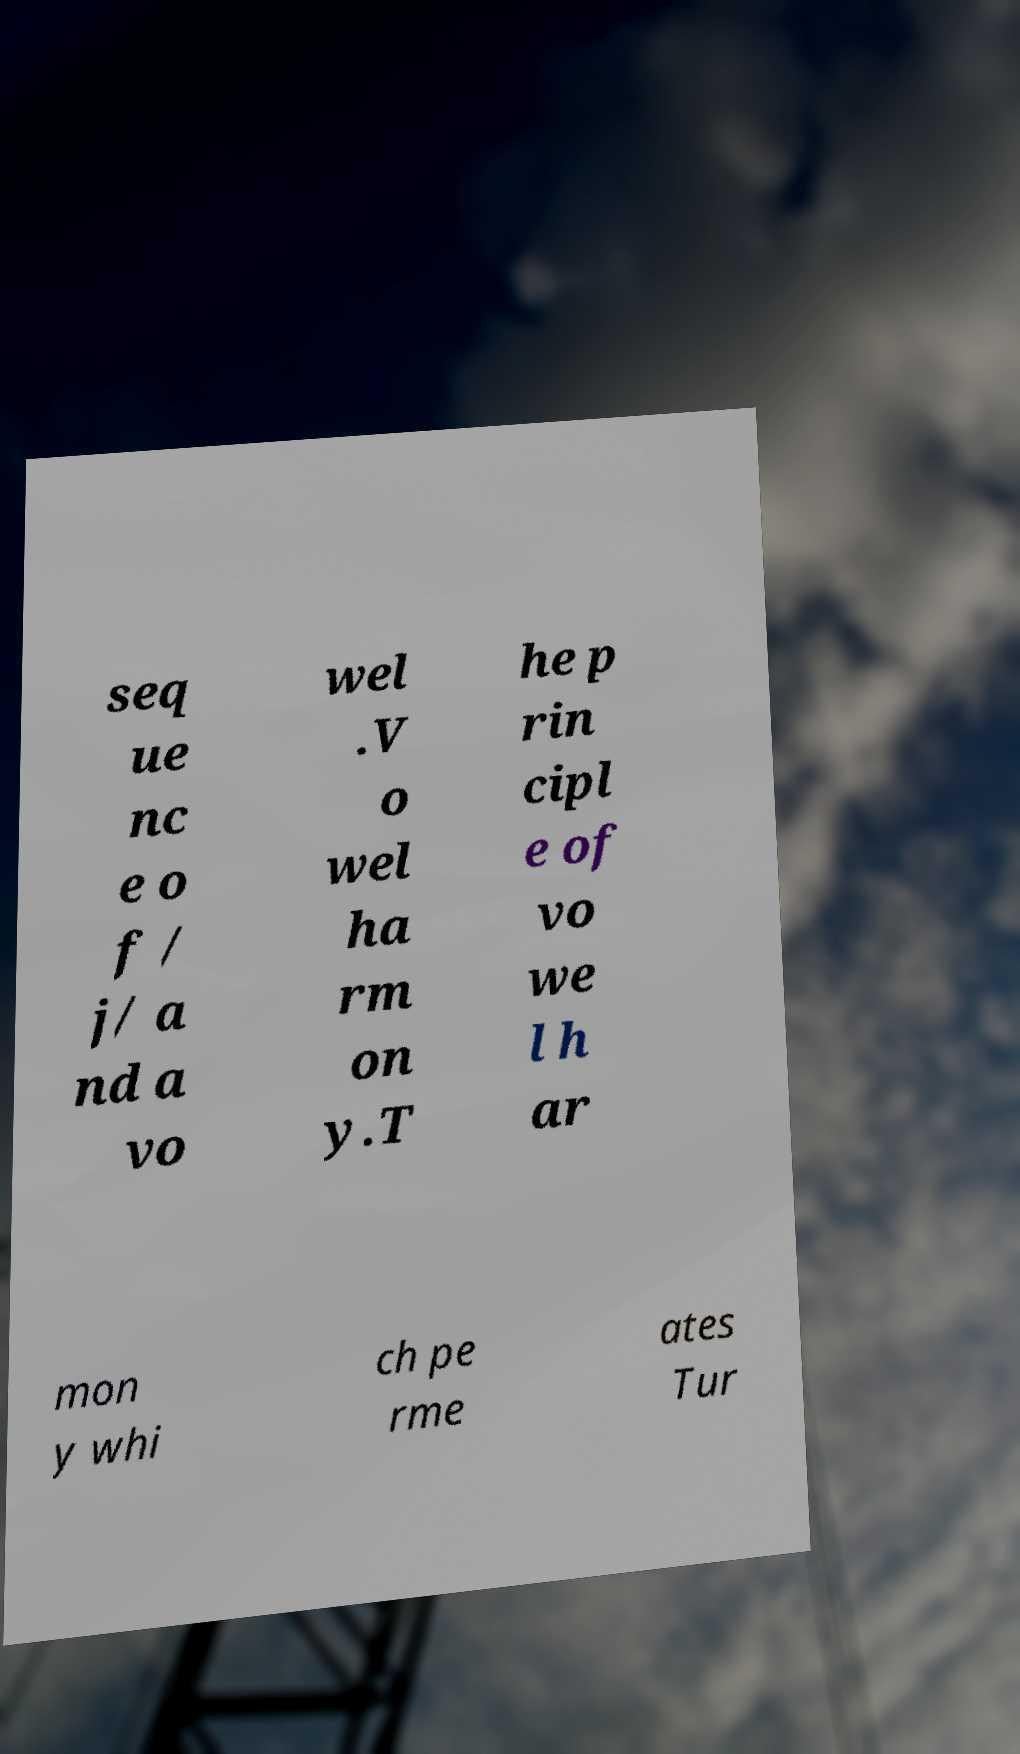There's text embedded in this image that I need extracted. Can you transcribe it verbatim? seq ue nc e o f / j/ a nd a vo wel .V o wel ha rm on y.T he p rin cipl e of vo we l h ar mon y whi ch pe rme ates Tur 